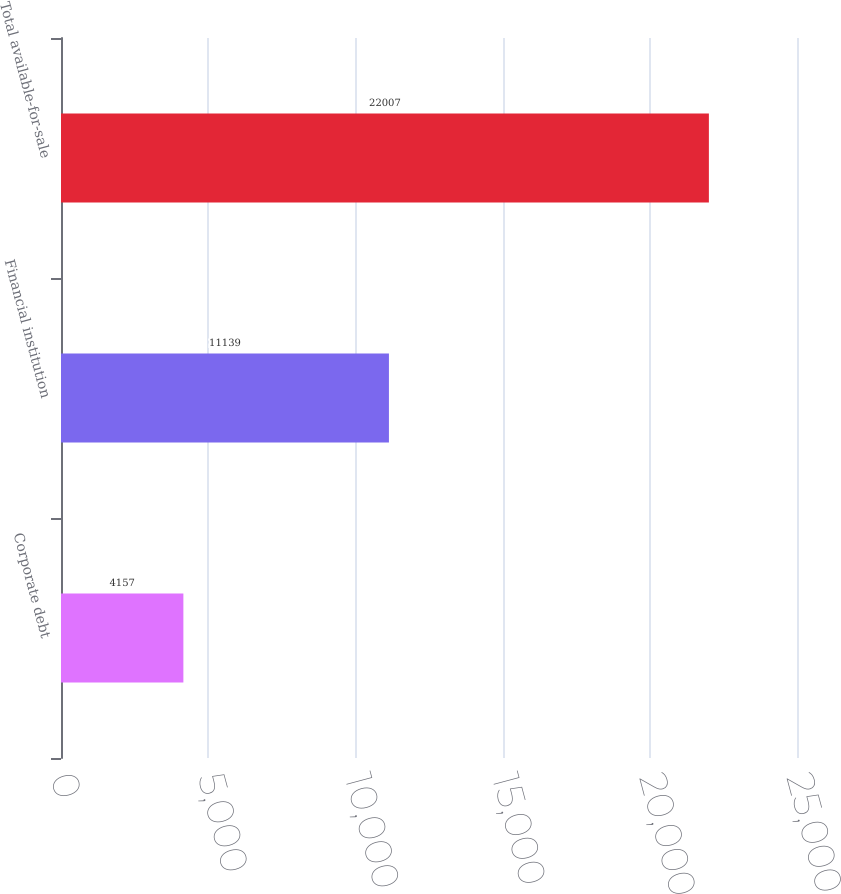Convert chart. <chart><loc_0><loc_0><loc_500><loc_500><bar_chart><fcel>Corporate debt<fcel>Financial institution<fcel>Total available-for-sale<nl><fcel>4157<fcel>11139<fcel>22007<nl></chart> 